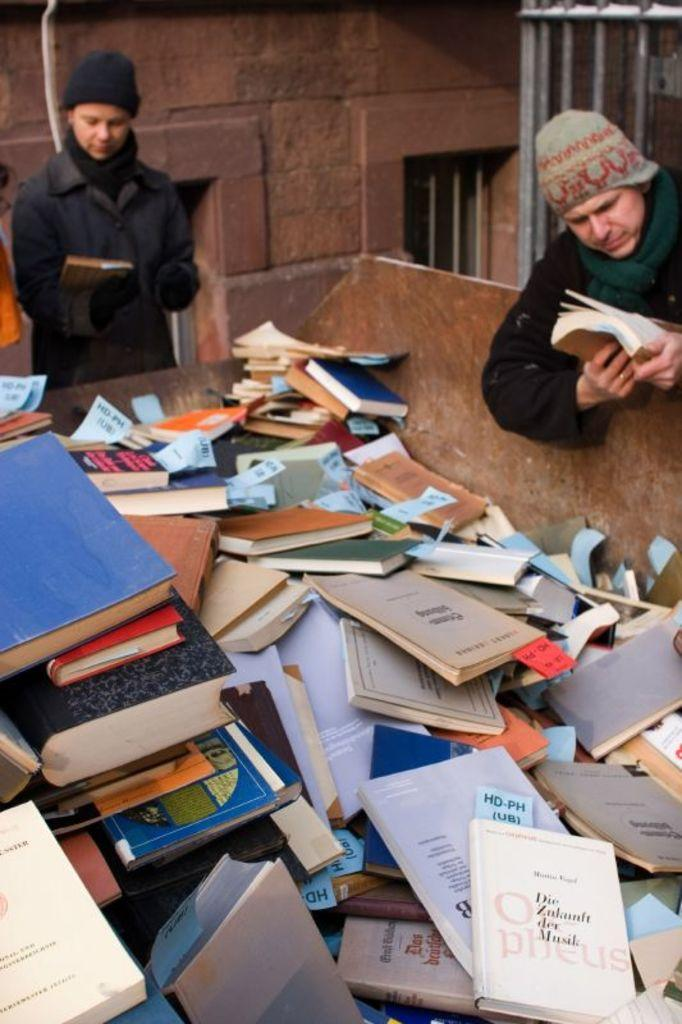What is the main subject of the image? The main subject of the image is many books on a platform. How many people are present in the image? There are two men present in the image, one on the left and one on the right. What are the men holding in their hands? Both men are holding books in their hands. What can be seen in the background of the image? There is a wall, windows, and a metal object in the background of the image. What type of jewel is the man on the left wearing in the image? There is no mention of any jewelry or jewels in the image; the men are holding books. 